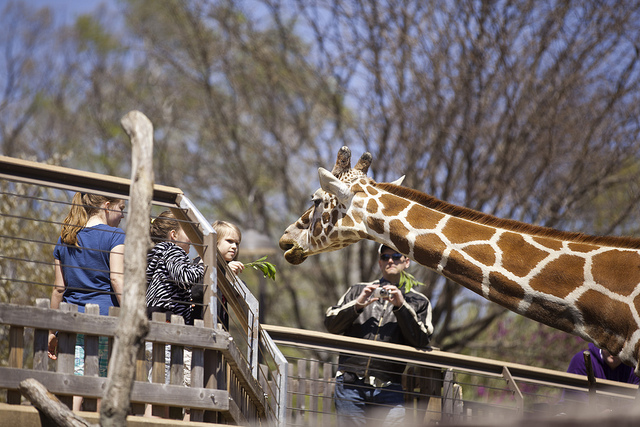How many people can be seen? 3 